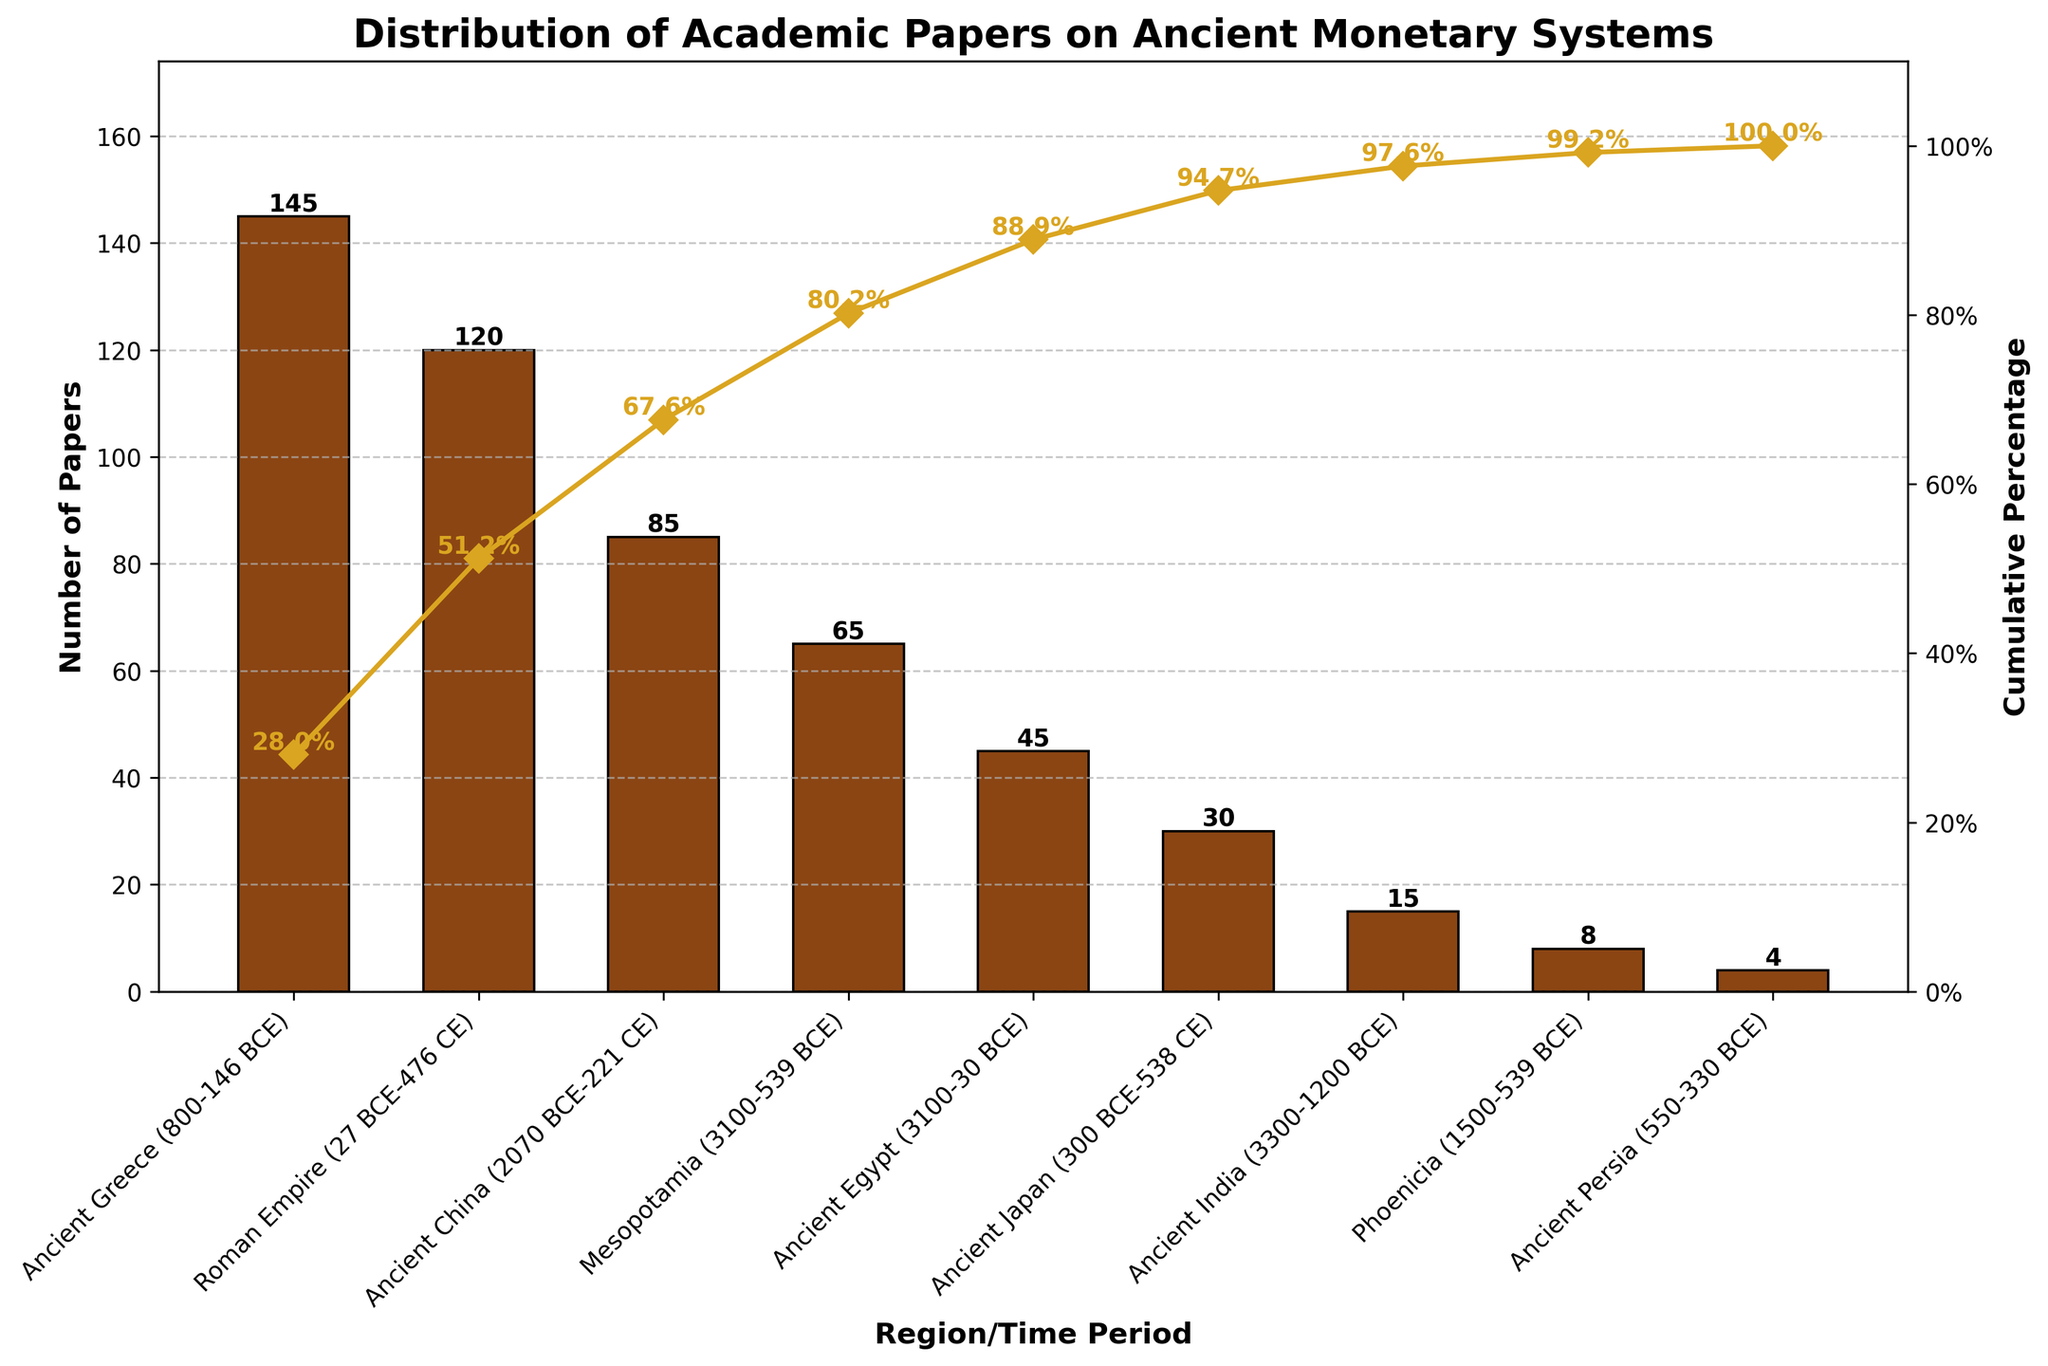How many papers are there on Ancient Greece? The number of papers can be seen on the bar corresponding to Ancient Greece. The label on top of the bar indicates the number of papers.
Answer: 145 What is the cumulative percentage for the Roman Empire? The cumulative percentage for the Roman Empire is shown on the line graph and indicated by the gold-colored marker. The label next to the marker shows the cumulative percentage.
Answer: 51.2% Which region has the lowest number of papers? By examining the heights of the bars, the shortest bar represents the region with the fewest papers. The label above the shortest bar indicates the number of papers for Ancient Persia.
Answer: Ancient Persia Compare the number of papers between Ancient China and Ancient Egypt. Which has more papers and by how many? Look at the bars for Ancient China and Ancient Egypt. Ancient China has 85 papers, while Ancient Egypt has 45. Subtracting, 85 - 45 = 40. Ancient China has 40 more papers.
Answer: Ancient China has 40 more papers What percentage of the total papers does Ancient Mesopotamia and Ancient Japan contribute together? Add the number of papers for Ancient Mesopotamia (65) and Ancient Japan (30), which totals to 95 papers. Look at the cumulative percentage line after Ancient Japan, which shows 94.7%. Subtract the cumulative percentage of Ancient Egypt (88.9%) to get the combined percentage for Ancient Mesopotamia and Ancient Japan, 94.7% - 88.9% = 5.8%.
Answer: 5.8% How many regions have more than 50 papers? Count the number of bars that have values greater than 50. Ancient Greece, Roman Empire, and Ancient China each have more than 50 papers.
Answer: 3 What is the cumulative percentage difference between Ancient Greece and Ancient India? The cumulative percentage for Ancient Greece is 28.0%, and for Ancient India it is 97.6%. Subtract these percentages, 97.6% - 28.0% = 69.6%.
Answer: 69.6% How does the number of papers on Ancient Japan compare to Ancient China? Compare the heights of the bars for Ancient Japan and Ancient China. Ancient Japan has 30 papers, while Ancient China has 85 papers, showing Ancient China has more papers.
Answer: Ancient China has more papers What is the trend of cumulative percentage from the first to the last region in the figure? Examine the cumulative percentage line which generally increases from left to right, reaching 100% by the last region (Ancient Persia).
Answer: It increases steadily Based on the Pareto principle (80/20 rule), do the first two regions account for 80% of the academic papers? Look at the cumulative percentages of the first two regions. Ancient Greece (28.0%) + Roman Empire (51.2%) = 79.2%, which is close but less than 80%.
Answer: No 